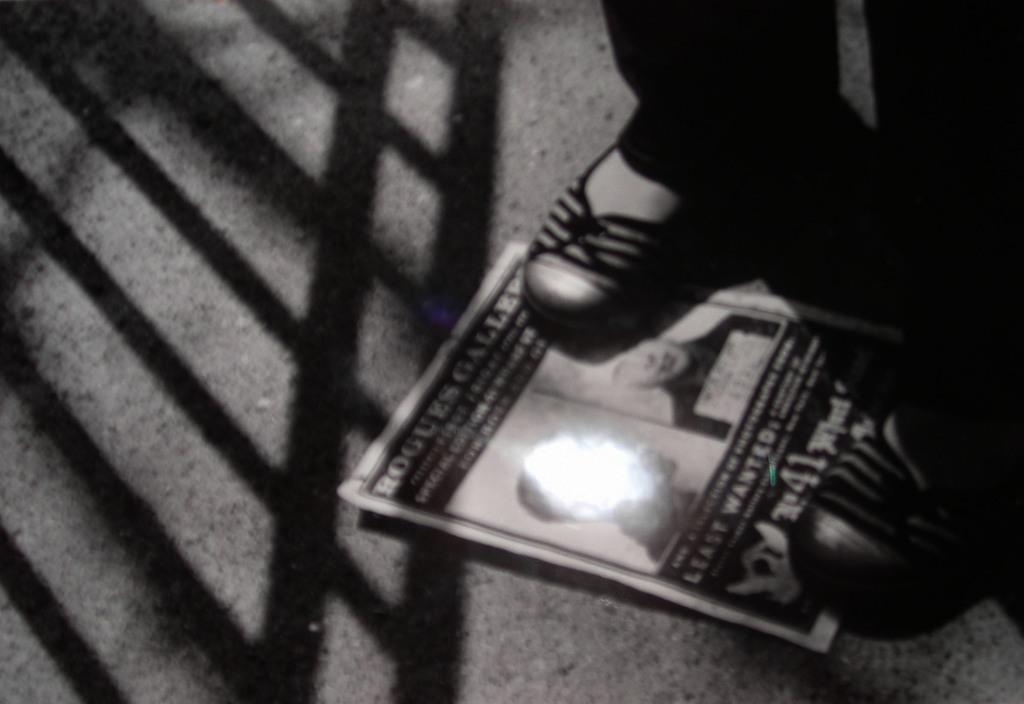How would you summarize this image in a sentence or two? In this picture we can see one person is standing on the paper, which is placed on the floor. 